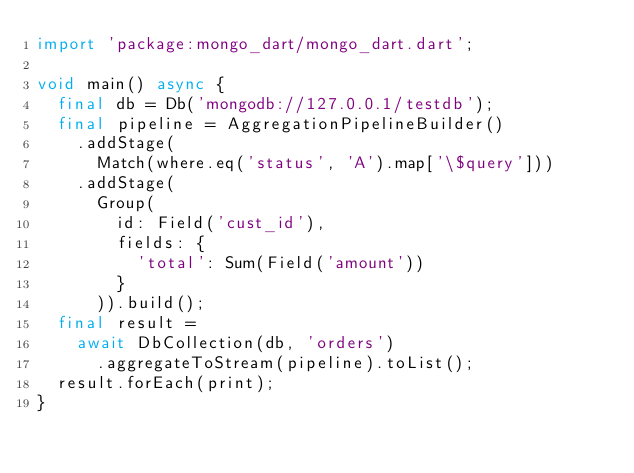Convert code to text. <code><loc_0><loc_0><loc_500><loc_500><_Dart_>import 'package:mongo_dart/mongo_dart.dart';

void main() async {
  final db = Db('mongodb://127.0.0.1/testdb');
  final pipeline = AggregationPipelineBuilder()
    .addStage(
      Match(where.eq('status', 'A').map['\$query']))
    .addStage(
      Group(
        id: Field('cust_id'),
        fields: {
          'total': Sum(Field('amount'))
        }
      )).build();
  final result =
    await DbCollection(db, 'orders')
      .aggregateToStream(pipeline).toList();
  result.forEach(print);
}</code> 